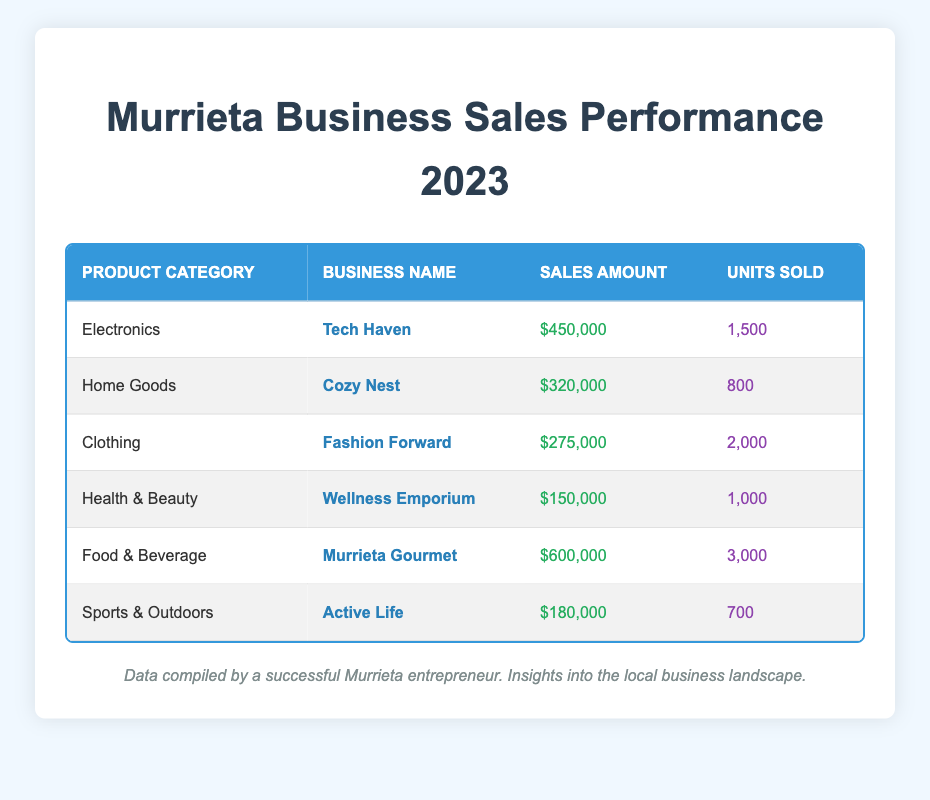What is the total sales amount for Electronics category? From the table, the sales amount listed for the Electronics category is $450,000.
Answer: $450,000 Which business achieved the highest sales in 2023? The table shows that the business with the highest sales is Murrieta Gourmet, with a sales amount of $600,000.
Answer: Murrieta Gourmet How many units were sold for the Clothing category? According to the table, Fashion Forward, the business under the Clothing category, sold a total of 2,000 units.
Answer: 2,000 Is the sales amount for Home Goods higher than that for Health & Beauty? The sales amount for Home Goods is $320,000, which is higher than the $150,000 for Health & Beauty. Therefore, the statement is true.
Answer: Yes What is the average number of units sold across all product categories? To calculate the average, sum the units sold (1,500 + 800 + 2,000 + 1,000 + 3,000 + 700 = 9,000) and divide by the number of categories (6). So, the average is 9,000 / 6 = 1,500.
Answer: 1,500 What is the sales amount difference between Food & Beverage and Sports & Outdoors? The sales amount for Food & Beverage is $600,000, while for Sports & Outdoors it's $180,000. The difference is $600,000 - $180,000 = $420,000.
Answer: $420,000 Which product category sold the lowest number of units? Comparing the units sold, Sports & Outdoors had the lowest at 700 units, while others sold more.
Answer: Sports & Outdoors Did Wellness Emporium have higher sales than Fashion Forward? The sales amount for Wellness Emporium is $150,000, and for Fashion Forward, it's $275,000, meaning Wellness Emporium did not have higher sales.
Answer: No What percentage of total sales does Electronics represent? Total sales amount is $450,000 + $320,000 + $275,000 + $150,000 + $600,000 + $180,000 = $1,975,000. The Electronics sales amount is $450,000. The percentage is ($450,000 / $1,975,000) * 100 ≈ 22.8%.
Answer: 22.8% 